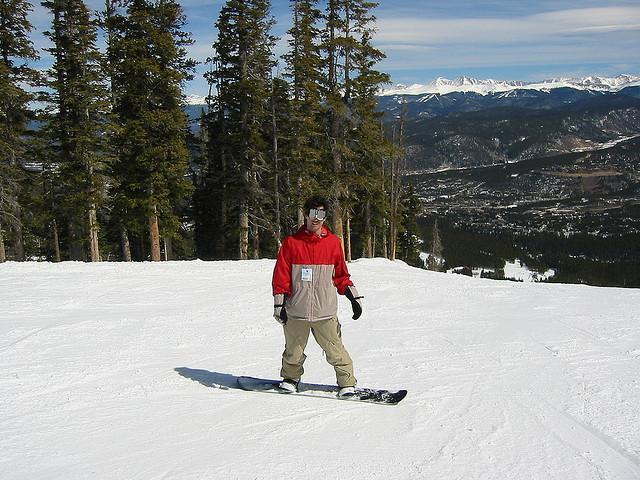How many white cars are there?
Give a very brief answer. 0. 